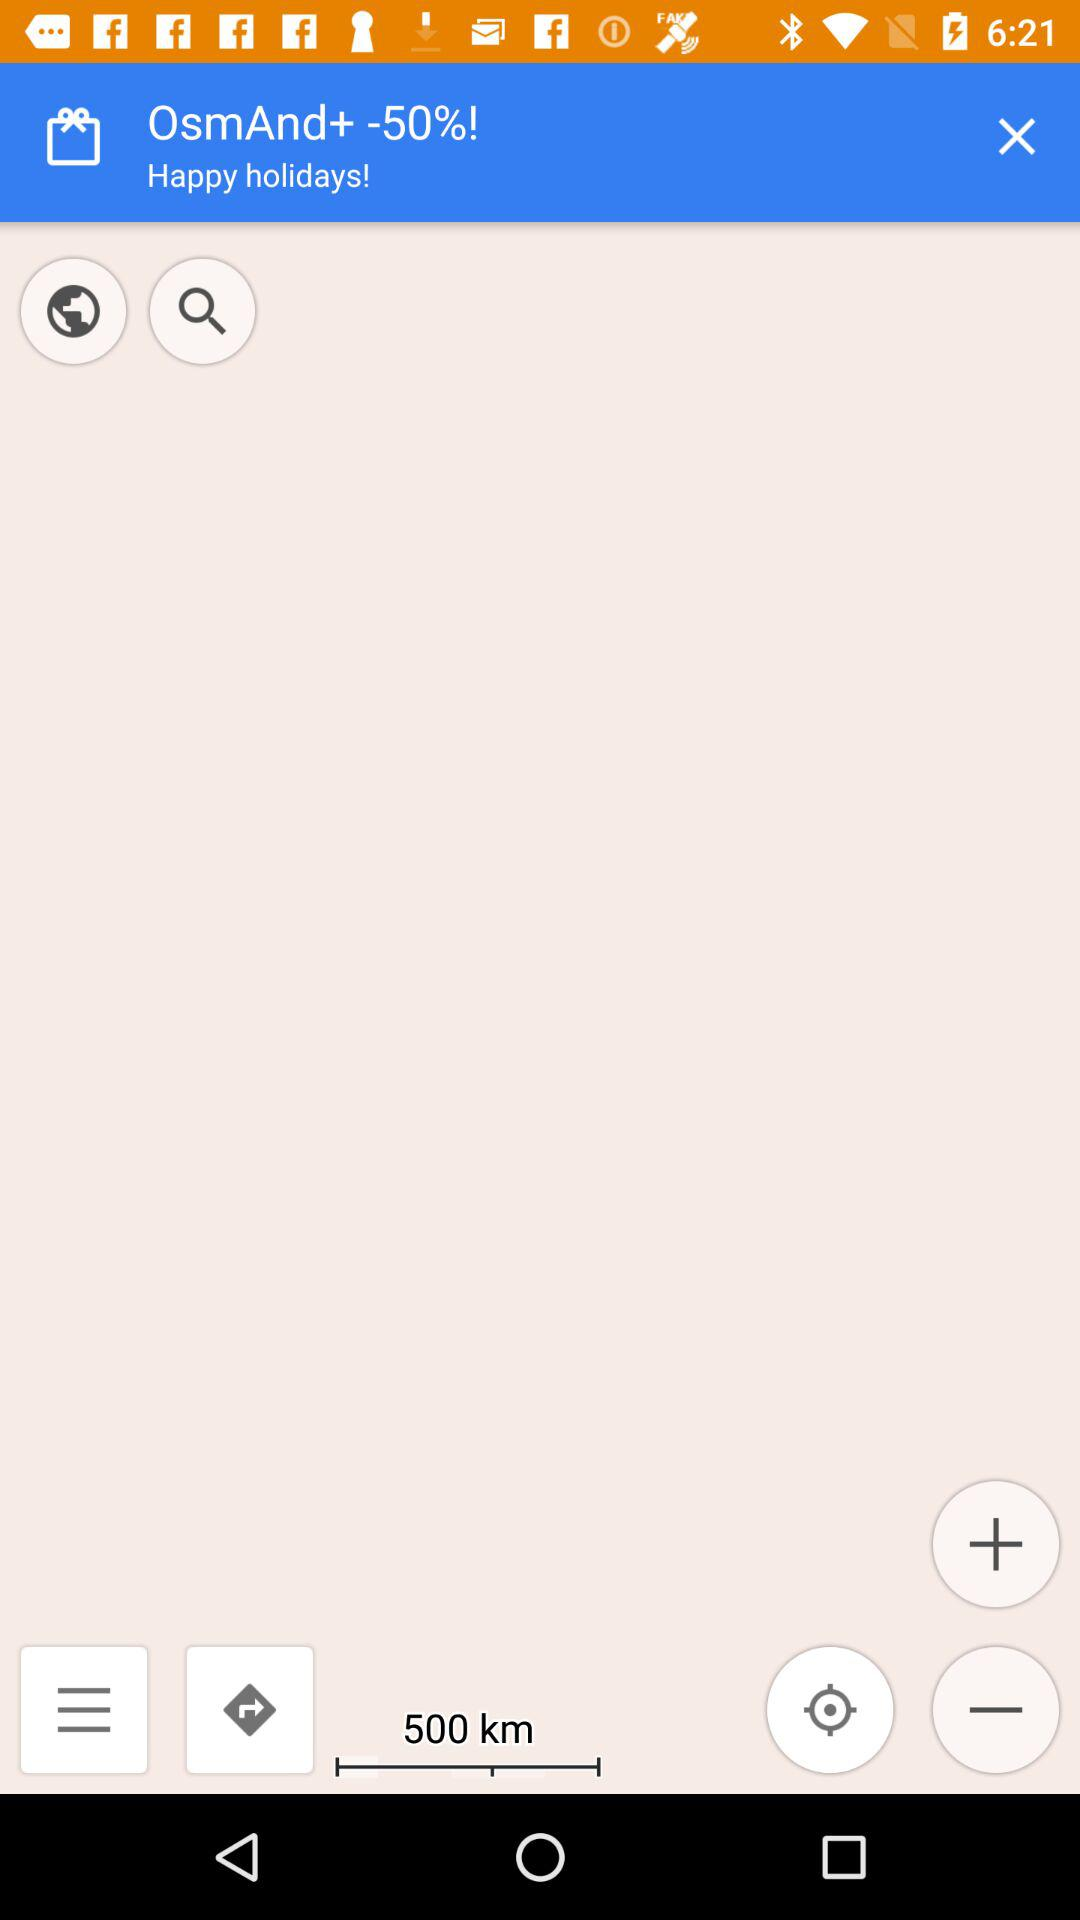What is the mentioned distance? The mentioned distance is 500 km. 